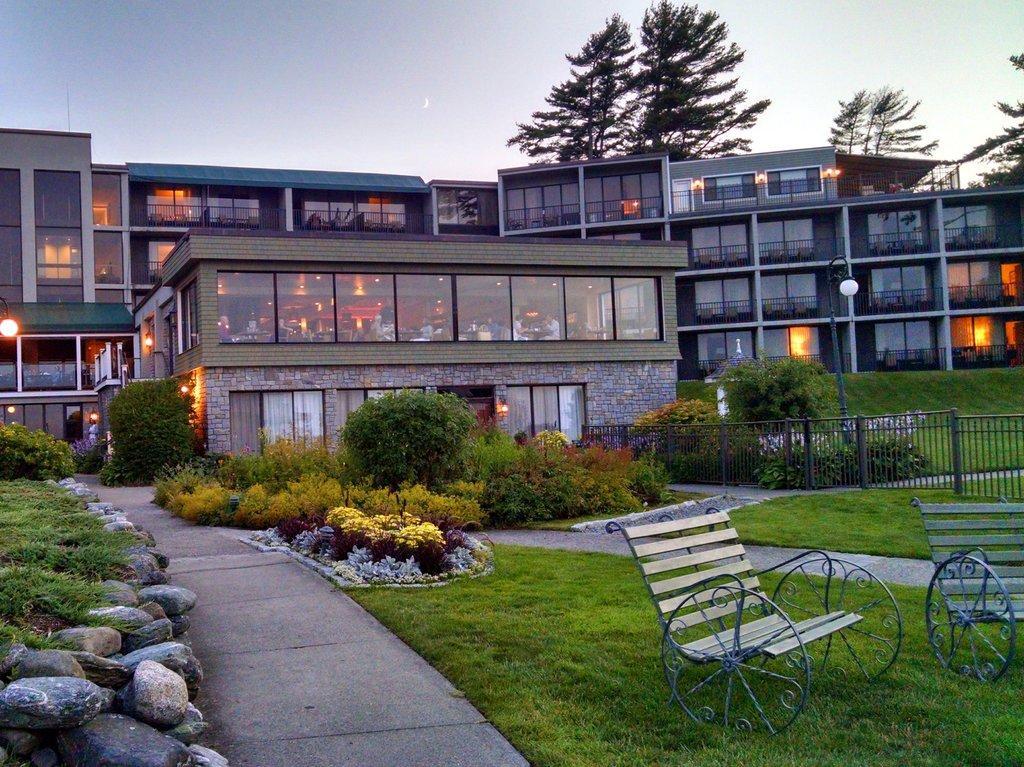Can you describe this image briefly? This is an outside view. At the bottom of the image I can see a path, garden in which I can see two benches, plants and some rocks. In the background there is a building, trees and poles. On the right side there is a railing. On the top of the image I can see the sky. 